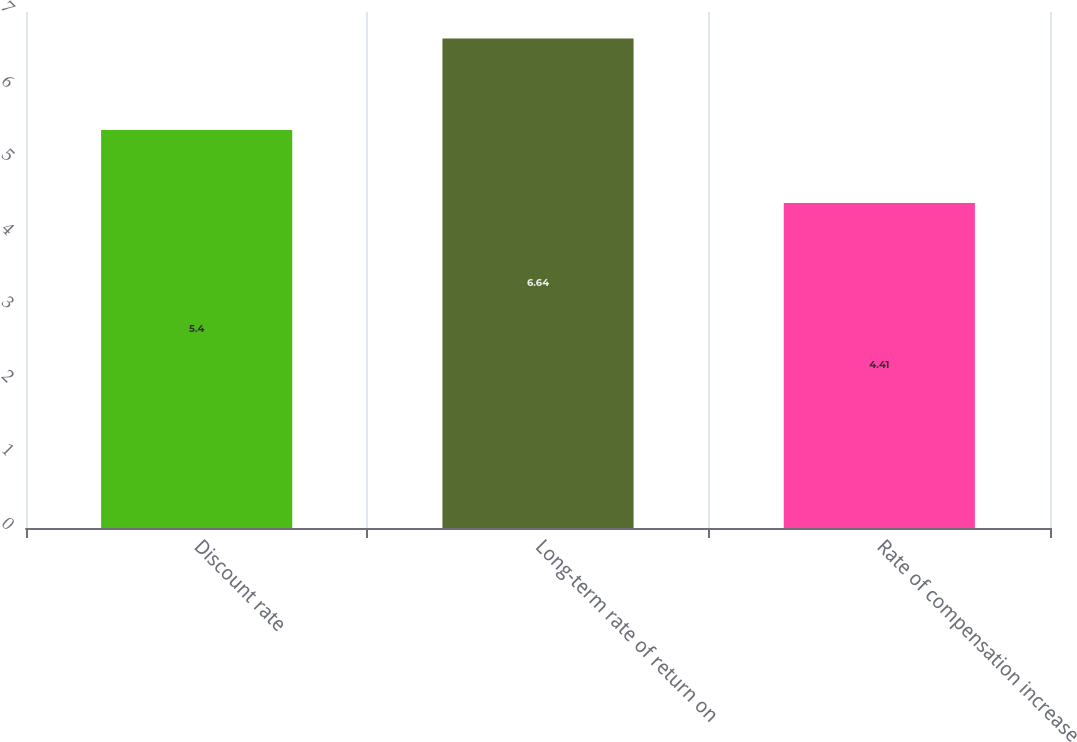<chart> <loc_0><loc_0><loc_500><loc_500><bar_chart><fcel>Discount rate<fcel>Long-term rate of return on<fcel>Rate of compensation increase<nl><fcel>5.4<fcel>6.64<fcel>4.41<nl></chart> 